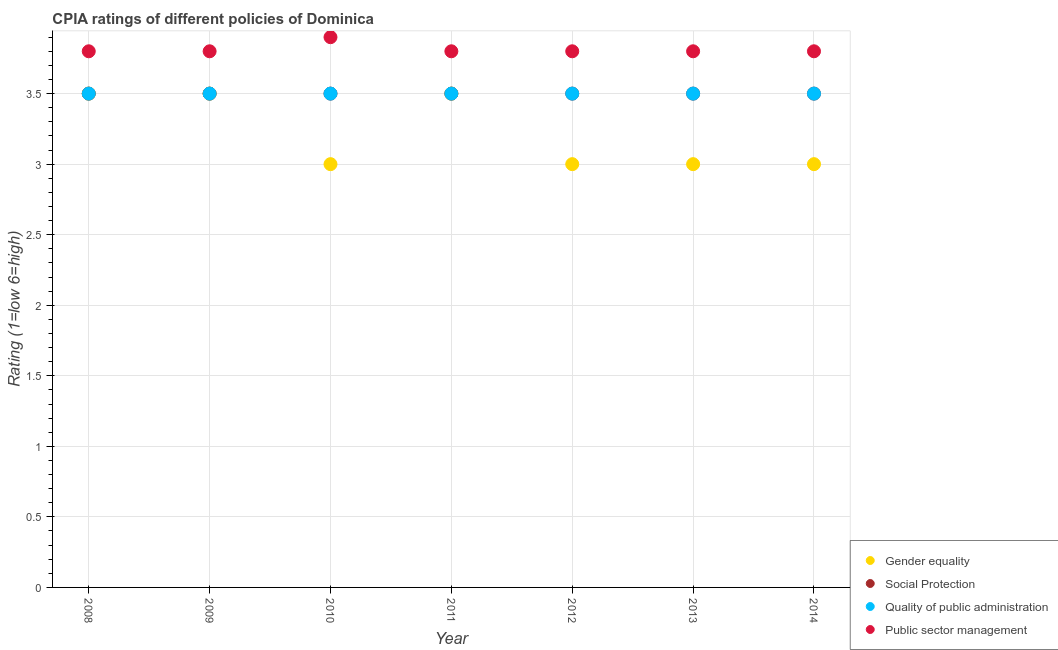Is the number of dotlines equal to the number of legend labels?
Your answer should be very brief. Yes. What is the cpia rating of gender equality in 2008?
Provide a succinct answer. 3.5. Across all years, what is the minimum cpia rating of quality of public administration?
Give a very brief answer. 3.5. In which year was the cpia rating of public sector management maximum?
Your response must be concise. 2010. In which year was the cpia rating of quality of public administration minimum?
Make the answer very short. 2008. What is the total cpia rating of public sector management in the graph?
Your answer should be compact. 26.7. What is the difference between the cpia rating of public sector management in 2010 and the cpia rating of quality of public administration in 2014?
Your response must be concise. 0.4. In the year 2013, what is the difference between the cpia rating of public sector management and cpia rating of gender equality?
Provide a short and direct response. 0.8. In how many years, is the cpia rating of gender equality greater than 1.2?
Give a very brief answer. 7. What is the ratio of the cpia rating of public sector management in 2008 to that in 2010?
Ensure brevity in your answer.  0.97. Is the difference between the cpia rating of social protection in 2011 and 2012 greater than the difference between the cpia rating of gender equality in 2011 and 2012?
Your response must be concise. No. What is the difference between the highest and the second highest cpia rating of social protection?
Ensure brevity in your answer.  0. Is it the case that in every year, the sum of the cpia rating of gender equality and cpia rating of social protection is greater than the cpia rating of quality of public administration?
Your answer should be compact. Yes. Does the cpia rating of social protection monotonically increase over the years?
Offer a terse response. No. Does the graph contain grids?
Your answer should be very brief. Yes. Where does the legend appear in the graph?
Keep it short and to the point. Bottom right. What is the title of the graph?
Give a very brief answer. CPIA ratings of different policies of Dominica. What is the label or title of the Y-axis?
Your response must be concise. Rating (1=low 6=high). What is the Rating (1=low 6=high) in Social Protection in 2008?
Ensure brevity in your answer.  3.5. What is the Rating (1=low 6=high) in Social Protection in 2009?
Your response must be concise. 3.5. What is the Rating (1=low 6=high) of Quality of public administration in 2009?
Give a very brief answer. 3.5. What is the Rating (1=low 6=high) in Gender equality in 2010?
Offer a terse response. 3. What is the Rating (1=low 6=high) of Social Protection in 2010?
Your response must be concise. 3.5. What is the Rating (1=low 6=high) in Quality of public administration in 2010?
Offer a terse response. 3.5. What is the Rating (1=low 6=high) of Public sector management in 2010?
Your answer should be very brief. 3.9. What is the Rating (1=low 6=high) of Quality of public administration in 2011?
Give a very brief answer. 3.5. What is the Rating (1=low 6=high) of Social Protection in 2012?
Offer a terse response. 3.5. What is the Rating (1=low 6=high) in Quality of public administration in 2012?
Your answer should be very brief. 3.5. What is the Rating (1=low 6=high) of Public sector management in 2012?
Ensure brevity in your answer.  3.8. What is the Rating (1=low 6=high) in Gender equality in 2014?
Provide a short and direct response. 3. What is the Rating (1=low 6=high) in Public sector management in 2014?
Your answer should be compact. 3.8. Across all years, what is the maximum Rating (1=low 6=high) of Gender equality?
Make the answer very short. 3.5. Across all years, what is the maximum Rating (1=low 6=high) in Public sector management?
Your answer should be very brief. 3.9. Across all years, what is the minimum Rating (1=low 6=high) in Gender equality?
Provide a succinct answer. 3. What is the total Rating (1=low 6=high) in Gender equality in the graph?
Ensure brevity in your answer.  22.5. What is the total Rating (1=low 6=high) of Quality of public administration in the graph?
Provide a succinct answer. 24.5. What is the total Rating (1=low 6=high) of Public sector management in the graph?
Offer a terse response. 26.7. What is the difference between the Rating (1=low 6=high) of Gender equality in 2008 and that in 2009?
Offer a very short reply. 0. What is the difference between the Rating (1=low 6=high) of Social Protection in 2008 and that in 2009?
Ensure brevity in your answer.  0. What is the difference between the Rating (1=low 6=high) in Social Protection in 2008 and that in 2010?
Offer a terse response. 0. What is the difference between the Rating (1=low 6=high) in Public sector management in 2008 and that in 2010?
Your answer should be compact. -0.1. What is the difference between the Rating (1=low 6=high) of Social Protection in 2008 and that in 2011?
Provide a succinct answer. 0. What is the difference between the Rating (1=low 6=high) in Quality of public administration in 2008 and that in 2011?
Provide a succinct answer. 0. What is the difference between the Rating (1=low 6=high) of Public sector management in 2008 and that in 2011?
Make the answer very short. 0. What is the difference between the Rating (1=low 6=high) in Quality of public administration in 2008 and that in 2012?
Provide a succinct answer. 0. What is the difference between the Rating (1=low 6=high) of Public sector management in 2008 and that in 2012?
Your answer should be compact. 0. What is the difference between the Rating (1=low 6=high) in Gender equality in 2008 and that in 2013?
Offer a very short reply. 0.5. What is the difference between the Rating (1=low 6=high) of Public sector management in 2008 and that in 2013?
Offer a very short reply. 0. What is the difference between the Rating (1=low 6=high) in Social Protection in 2008 and that in 2014?
Your answer should be very brief. 0. What is the difference between the Rating (1=low 6=high) of Quality of public administration in 2008 and that in 2014?
Your answer should be very brief. 0. What is the difference between the Rating (1=low 6=high) in Social Protection in 2009 and that in 2010?
Provide a short and direct response. 0. What is the difference between the Rating (1=low 6=high) of Public sector management in 2009 and that in 2010?
Your response must be concise. -0.1. What is the difference between the Rating (1=low 6=high) in Gender equality in 2009 and that in 2011?
Provide a succinct answer. 0. What is the difference between the Rating (1=low 6=high) in Quality of public administration in 2009 and that in 2011?
Ensure brevity in your answer.  0. What is the difference between the Rating (1=low 6=high) of Public sector management in 2009 and that in 2011?
Give a very brief answer. 0. What is the difference between the Rating (1=low 6=high) in Social Protection in 2009 and that in 2012?
Ensure brevity in your answer.  0. What is the difference between the Rating (1=low 6=high) of Quality of public administration in 2009 and that in 2012?
Offer a terse response. 0. What is the difference between the Rating (1=low 6=high) in Gender equality in 2009 and that in 2013?
Make the answer very short. 0.5. What is the difference between the Rating (1=low 6=high) of Social Protection in 2009 and that in 2013?
Provide a succinct answer. 0. What is the difference between the Rating (1=low 6=high) in Quality of public administration in 2009 and that in 2013?
Make the answer very short. 0. What is the difference between the Rating (1=low 6=high) in Quality of public administration in 2009 and that in 2014?
Provide a short and direct response. 0. What is the difference between the Rating (1=low 6=high) in Public sector management in 2009 and that in 2014?
Give a very brief answer. 0. What is the difference between the Rating (1=low 6=high) in Gender equality in 2010 and that in 2011?
Offer a terse response. -0.5. What is the difference between the Rating (1=low 6=high) in Public sector management in 2010 and that in 2013?
Offer a very short reply. 0.1. What is the difference between the Rating (1=low 6=high) of Public sector management in 2010 and that in 2014?
Offer a terse response. 0.1. What is the difference between the Rating (1=low 6=high) of Public sector management in 2011 and that in 2012?
Ensure brevity in your answer.  0. What is the difference between the Rating (1=low 6=high) of Quality of public administration in 2011 and that in 2013?
Your answer should be compact. 0. What is the difference between the Rating (1=low 6=high) in Public sector management in 2011 and that in 2013?
Offer a terse response. 0. What is the difference between the Rating (1=low 6=high) in Quality of public administration in 2011 and that in 2014?
Make the answer very short. 0. What is the difference between the Rating (1=low 6=high) in Public sector management in 2012 and that in 2013?
Make the answer very short. 0. What is the difference between the Rating (1=low 6=high) in Social Protection in 2012 and that in 2014?
Ensure brevity in your answer.  0. What is the difference between the Rating (1=low 6=high) of Public sector management in 2012 and that in 2014?
Provide a short and direct response. 0. What is the difference between the Rating (1=low 6=high) in Social Protection in 2013 and that in 2014?
Make the answer very short. 0. What is the difference between the Rating (1=low 6=high) in Public sector management in 2013 and that in 2014?
Provide a succinct answer. 0. What is the difference between the Rating (1=low 6=high) of Gender equality in 2008 and the Rating (1=low 6=high) of Quality of public administration in 2009?
Provide a short and direct response. 0. What is the difference between the Rating (1=low 6=high) in Quality of public administration in 2008 and the Rating (1=low 6=high) in Public sector management in 2009?
Make the answer very short. -0.3. What is the difference between the Rating (1=low 6=high) in Gender equality in 2008 and the Rating (1=low 6=high) in Social Protection in 2010?
Provide a succinct answer. 0. What is the difference between the Rating (1=low 6=high) in Gender equality in 2008 and the Rating (1=low 6=high) in Public sector management in 2010?
Provide a short and direct response. -0.4. What is the difference between the Rating (1=low 6=high) of Social Protection in 2008 and the Rating (1=low 6=high) of Quality of public administration in 2010?
Provide a short and direct response. 0. What is the difference between the Rating (1=low 6=high) in Gender equality in 2008 and the Rating (1=low 6=high) in Social Protection in 2011?
Provide a succinct answer. 0. What is the difference between the Rating (1=low 6=high) in Gender equality in 2008 and the Rating (1=low 6=high) in Quality of public administration in 2011?
Your answer should be compact. 0. What is the difference between the Rating (1=low 6=high) in Gender equality in 2008 and the Rating (1=low 6=high) in Public sector management in 2011?
Your answer should be very brief. -0.3. What is the difference between the Rating (1=low 6=high) in Social Protection in 2008 and the Rating (1=low 6=high) in Public sector management in 2011?
Provide a succinct answer. -0.3. What is the difference between the Rating (1=low 6=high) in Quality of public administration in 2008 and the Rating (1=low 6=high) in Public sector management in 2011?
Provide a short and direct response. -0.3. What is the difference between the Rating (1=low 6=high) in Gender equality in 2008 and the Rating (1=low 6=high) in Social Protection in 2012?
Your response must be concise. 0. What is the difference between the Rating (1=low 6=high) in Quality of public administration in 2008 and the Rating (1=low 6=high) in Public sector management in 2012?
Give a very brief answer. -0.3. What is the difference between the Rating (1=low 6=high) of Gender equality in 2008 and the Rating (1=low 6=high) of Social Protection in 2013?
Your response must be concise. 0. What is the difference between the Rating (1=low 6=high) in Gender equality in 2008 and the Rating (1=low 6=high) in Quality of public administration in 2013?
Make the answer very short. 0. What is the difference between the Rating (1=low 6=high) of Social Protection in 2008 and the Rating (1=low 6=high) of Public sector management in 2013?
Your answer should be compact. -0.3. What is the difference between the Rating (1=low 6=high) in Quality of public administration in 2008 and the Rating (1=low 6=high) in Public sector management in 2014?
Keep it short and to the point. -0.3. What is the difference between the Rating (1=low 6=high) of Gender equality in 2009 and the Rating (1=low 6=high) of Social Protection in 2010?
Offer a very short reply. 0. What is the difference between the Rating (1=low 6=high) of Gender equality in 2009 and the Rating (1=low 6=high) of Quality of public administration in 2010?
Provide a succinct answer. 0. What is the difference between the Rating (1=low 6=high) in Social Protection in 2009 and the Rating (1=low 6=high) in Quality of public administration in 2010?
Make the answer very short. 0. What is the difference between the Rating (1=low 6=high) of Social Protection in 2009 and the Rating (1=low 6=high) of Public sector management in 2010?
Your response must be concise. -0.4. What is the difference between the Rating (1=low 6=high) in Gender equality in 2009 and the Rating (1=low 6=high) in Social Protection in 2011?
Your response must be concise. 0. What is the difference between the Rating (1=low 6=high) in Gender equality in 2009 and the Rating (1=low 6=high) in Public sector management in 2011?
Offer a very short reply. -0.3. What is the difference between the Rating (1=low 6=high) of Social Protection in 2009 and the Rating (1=low 6=high) of Public sector management in 2011?
Make the answer very short. -0.3. What is the difference between the Rating (1=low 6=high) in Gender equality in 2009 and the Rating (1=low 6=high) in Quality of public administration in 2012?
Your answer should be very brief. 0. What is the difference between the Rating (1=low 6=high) in Gender equality in 2009 and the Rating (1=low 6=high) in Public sector management in 2012?
Offer a terse response. -0.3. What is the difference between the Rating (1=low 6=high) in Quality of public administration in 2009 and the Rating (1=low 6=high) in Public sector management in 2012?
Provide a short and direct response. -0.3. What is the difference between the Rating (1=low 6=high) in Gender equality in 2009 and the Rating (1=low 6=high) in Social Protection in 2013?
Provide a succinct answer. 0. What is the difference between the Rating (1=low 6=high) in Social Protection in 2009 and the Rating (1=low 6=high) in Public sector management in 2013?
Ensure brevity in your answer.  -0.3. What is the difference between the Rating (1=low 6=high) of Quality of public administration in 2009 and the Rating (1=low 6=high) of Public sector management in 2013?
Keep it short and to the point. -0.3. What is the difference between the Rating (1=low 6=high) of Gender equality in 2009 and the Rating (1=low 6=high) of Social Protection in 2014?
Keep it short and to the point. 0. What is the difference between the Rating (1=low 6=high) of Gender equality in 2009 and the Rating (1=low 6=high) of Quality of public administration in 2014?
Offer a terse response. 0. What is the difference between the Rating (1=low 6=high) in Gender equality in 2009 and the Rating (1=low 6=high) in Public sector management in 2014?
Provide a succinct answer. -0.3. What is the difference between the Rating (1=low 6=high) of Gender equality in 2010 and the Rating (1=low 6=high) of Quality of public administration in 2011?
Provide a short and direct response. -0.5. What is the difference between the Rating (1=low 6=high) in Gender equality in 2010 and the Rating (1=low 6=high) in Public sector management in 2011?
Offer a very short reply. -0.8. What is the difference between the Rating (1=low 6=high) in Quality of public administration in 2010 and the Rating (1=low 6=high) in Public sector management in 2011?
Ensure brevity in your answer.  -0.3. What is the difference between the Rating (1=low 6=high) of Gender equality in 2010 and the Rating (1=low 6=high) of Public sector management in 2012?
Provide a short and direct response. -0.8. What is the difference between the Rating (1=low 6=high) of Social Protection in 2010 and the Rating (1=low 6=high) of Quality of public administration in 2012?
Offer a terse response. 0. What is the difference between the Rating (1=low 6=high) in Social Protection in 2010 and the Rating (1=low 6=high) in Public sector management in 2012?
Provide a succinct answer. -0.3. What is the difference between the Rating (1=low 6=high) in Gender equality in 2010 and the Rating (1=low 6=high) in Quality of public administration in 2013?
Offer a very short reply. -0.5. What is the difference between the Rating (1=low 6=high) of Gender equality in 2010 and the Rating (1=low 6=high) of Public sector management in 2013?
Give a very brief answer. -0.8. What is the difference between the Rating (1=low 6=high) in Social Protection in 2010 and the Rating (1=low 6=high) in Quality of public administration in 2013?
Ensure brevity in your answer.  0. What is the difference between the Rating (1=low 6=high) in Social Protection in 2010 and the Rating (1=low 6=high) in Public sector management in 2013?
Ensure brevity in your answer.  -0.3. What is the difference between the Rating (1=low 6=high) of Quality of public administration in 2010 and the Rating (1=low 6=high) of Public sector management in 2013?
Make the answer very short. -0.3. What is the difference between the Rating (1=low 6=high) of Gender equality in 2010 and the Rating (1=low 6=high) of Social Protection in 2014?
Offer a very short reply. -0.5. What is the difference between the Rating (1=low 6=high) in Social Protection in 2010 and the Rating (1=low 6=high) in Public sector management in 2014?
Offer a very short reply. -0.3. What is the difference between the Rating (1=low 6=high) of Gender equality in 2011 and the Rating (1=low 6=high) of Quality of public administration in 2012?
Provide a succinct answer. 0. What is the difference between the Rating (1=low 6=high) of Gender equality in 2011 and the Rating (1=low 6=high) of Public sector management in 2012?
Give a very brief answer. -0.3. What is the difference between the Rating (1=low 6=high) of Gender equality in 2011 and the Rating (1=low 6=high) of Quality of public administration in 2013?
Keep it short and to the point. 0. What is the difference between the Rating (1=low 6=high) in Gender equality in 2011 and the Rating (1=low 6=high) in Public sector management in 2013?
Give a very brief answer. -0.3. What is the difference between the Rating (1=low 6=high) of Social Protection in 2011 and the Rating (1=low 6=high) of Quality of public administration in 2013?
Make the answer very short. 0. What is the difference between the Rating (1=low 6=high) of Quality of public administration in 2011 and the Rating (1=low 6=high) of Public sector management in 2013?
Your response must be concise. -0.3. What is the difference between the Rating (1=low 6=high) of Gender equality in 2011 and the Rating (1=low 6=high) of Social Protection in 2014?
Make the answer very short. 0. What is the difference between the Rating (1=low 6=high) in Gender equality in 2011 and the Rating (1=low 6=high) in Public sector management in 2014?
Provide a short and direct response. -0.3. What is the difference between the Rating (1=low 6=high) in Social Protection in 2011 and the Rating (1=low 6=high) in Quality of public administration in 2014?
Offer a very short reply. 0. What is the difference between the Rating (1=low 6=high) in Gender equality in 2012 and the Rating (1=low 6=high) in Public sector management in 2013?
Provide a short and direct response. -0.8. What is the difference between the Rating (1=low 6=high) in Social Protection in 2012 and the Rating (1=low 6=high) in Public sector management in 2013?
Your answer should be compact. -0.3. What is the difference between the Rating (1=low 6=high) of Quality of public administration in 2012 and the Rating (1=low 6=high) of Public sector management in 2013?
Offer a very short reply. -0.3. What is the difference between the Rating (1=low 6=high) of Gender equality in 2012 and the Rating (1=low 6=high) of Social Protection in 2014?
Your answer should be compact. -0.5. What is the difference between the Rating (1=low 6=high) of Gender equality in 2012 and the Rating (1=low 6=high) of Quality of public administration in 2014?
Offer a very short reply. -0.5. What is the difference between the Rating (1=low 6=high) in Gender equality in 2012 and the Rating (1=low 6=high) in Public sector management in 2014?
Offer a terse response. -0.8. What is the difference between the Rating (1=low 6=high) of Quality of public administration in 2012 and the Rating (1=low 6=high) of Public sector management in 2014?
Make the answer very short. -0.3. What is the difference between the Rating (1=low 6=high) of Gender equality in 2013 and the Rating (1=low 6=high) of Social Protection in 2014?
Ensure brevity in your answer.  -0.5. What is the difference between the Rating (1=low 6=high) in Gender equality in 2013 and the Rating (1=low 6=high) in Public sector management in 2014?
Give a very brief answer. -0.8. What is the difference between the Rating (1=low 6=high) of Social Protection in 2013 and the Rating (1=low 6=high) of Public sector management in 2014?
Your answer should be very brief. -0.3. What is the average Rating (1=low 6=high) in Gender equality per year?
Make the answer very short. 3.21. What is the average Rating (1=low 6=high) in Quality of public administration per year?
Ensure brevity in your answer.  3.5. What is the average Rating (1=low 6=high) in Public sector management per year?
Offer a terse response. 3.81. In the year 2008, what is the difference between the Rating (1=low 6=high) in Gender equality and Rating (1=low 6=high) in Quality of public administration?
Keep it short and to the point. 0. In the year 2008, what is the difference between the Rating (1=low 6=high) in Social Protection and Rating (1=low 6=high) in Quality of public administration?
Give a very brief answer. 0. In the year 2009, what is the difference between the Rating (1=low 6=high) in Gender equality and Rating (1=low 6=high) in Social Protection?
Provide a succinct answer. 0. In the year 2009, what is the difference between the Rating (1=low 6=high) of Gender equality and Rating (1=low 6=high) of Quality of public administration?
Provide a short and direct response. 0. In the year 2009, what is the difference between the Rating (1=low 6=high) of Gender equality and Rating (1=low 6=high) of Public sector management?
Provide a short and direct response. -0.3. In the year 2009, what is the difference between the Rating (1=low 6=high) of Social Protection and Rating (1=low 6=high) of Public sector management?
Keep it short and to the point. -0.3. In the year 2009, what is the difference between the Rating (1=low 6=high) of Quality of public administration and Rating (1=low 6=high) of Public sector management?
Offer a terse response. -0.3. In the year 2010, what is the difference between the Rating (1=low 6=high) of Gender equality and Rating (1=low 6=high) of Quality of public administration?
Provide a short and direct response. -0.5. In the year 2010, what is the difference between the Rating (1=low 6=high) in Quality of public administration and Rating (1=low 6=high) in Public sector management?
Your answer should be compact. -0.4. In the year 2011, what is the difference between the Rating (1=low 6=high) in Gender equality and Rating (1=low 6=high) in Quality of public administration?
Make the answer very short. 0. In the year 2011, what is the difference between the Rating (1=low 6=high) in Social Protection and Rating (1=low 6=high) in Public sector management?
Your response must be concise. -0.3. In the year 2011, what is the difference between the Rating (1=low 6=high) in Quality of public administration and Rating (1=low 6=high) in Public sector management?
Keep it short and to the point. -0.3. In the year 2012, what is the difference between the Rating (1=low 6=high) in Gender equality and Rating (1=low 6=high) in Social Protection?
Give a very brief answer. -0.5. In the year 2012, what is the difference between the Rating (1=low 6=high) in Social Protection and Rating (1=low 6=high) in Quality of public administration?
Offer a very short reply. 0. In the year 2012, what is the difference between the Rating (1=low 6=high) of Social Protection and Rating (1=low 6=high) of Public sector management?
Your answer should be very brief. -0.3. In the year 2012, what is the difference between the Rating (1=low 6=high) of Quality of public administration and Rating (1=low 6=high) of Public sector management?
Ensure brevity in your answer.  -0.3. In the year 2013, what is the difference between the Rating (1=low 6=high) of Gender equality and Rating (1=low 6=high) of Quality of public administration?
Your response must be concise. -0.5. In the year 2013, what is the difference between the Rating (1=low 6=high) in Gender equality and Rating (1=low 6=high) in Public sector management?
Your response must be concise. -0.8. In the year 2013, what is the difference between the Rating (1=low 6=high) of Social Protection and Rating (1=low 6=high) of Public sector management?
Ensure brevity in your answer.  -0.3. In the year 2013, what is the difference between the Rating (1=low 6=high) of Quality of public administration and Rating (1=low 6=high) of Public sector management?
Your response must be concise. -0.3. In the year 2014, what is the difference between the Rating (1=low 6=high) in Gender equality and Rating (1=low 6=high) in Social Protection?
Provide a short and direct response. -0.5. In the year 2014, what is the difference between the Rating (1=low 6=high) in Gender equality and Rating (1=low 6=high) in Quality of public administration?
Keep it short and to the point. -0.5. In the year 2014, what is the difference between the Rating (1=low 6=high) in Gender equality and Rating (1=low 6=high) in Public sector management?
Provide a succinct answer. -0.8. In the year 2014, what is the difference between the Rating (1=low 6=high) of Social Protection and Rating (1=low 6=high) of Public sector management?
Provide a short and direct response. -0.3. What is the ratio of the Rating (1=low 6=high) of Gender equality in 2008 to that in 2009?
Provide a short and direct response. 1. What is the ratio of the Rating (1=low 6=high) in Gender equality in 2008 to that in 2010?
Ensure brevity in your answer.  1.17. What is the ratio of the Rating (1=low 6=high) in Public sector management in 2008 to that in 2010?
Keep it short and to the point. 0.97. What is the ratio of the Rating (1=low 6=high) of Social Protection in 2008 to that in 2011?
Your response must be concise. 1. What is the ratio of the Rating (1=low 6=high) in Public sector management in 2008 to that in 2011?
Ensure brevity in your answer.  1. What is the ratio of the Rating (1=low 6=high) in Social Protection in 2008 to that in 2012?
Ensure brevity in your answer.  1. What is the ratio of the Rating (1=low 6=high) in Quality of public administration in 2008 to that in 2012?
Your answer should be very brief. 1. What is the ratio of the Rating (1=low 6=high) of Gender equality in 2008 to that in 2013?
Provide a succinct answer. 1.17. What is the ratio of the Rating (1=low 6=high) in Quality of public administration in 2008 to that in 2013?
Your answer should be very brief. 1. What is the ratio of the Rating (1=low 6=high) of Gender equality in 2008 to that in 2014?
Provide a succinct answer. 1.17. What is the ratio of the Rating (1=low 6=high) of Quality of public administration in 2008 to that in 2014?
Your answer should be very brief. 1. What is the ratio of the Rating (1=low 6=high) of Public sector management in 2008 to that in 2014?
Provide a succinct answer. 1. What is the ratio of the Rating (1=low 6=high) in Gender equality in 2009 to that in 2010?
Offer a very short reply. 1.17. What is the ratio of the Rating (1=low 6=high) of Public sector management in 2009 to that in 2010?
Provide a succinct answer. 0.97. What is the ratio of the Rating (1=low 6=high) in Gender equality in 2009 to that in 2011?
Your answer should be compact. 1. What is the ratio of the Rating (1=low 6=high) in Public sector management in 2009 to that in 2011?
Ensure brevity in your answer.  1. What is the ratio of the Rating (1=low 6=high) of Quality of public administration in 2009 to that in 2012?
Your response must be concise. 1. What is the ratio of the Rating (1=low 6=high) in Public sector management in 2009 to that in 2012?
Ensure brevity in your answer.  1. What is the ratio of the Rating (1=low 6=high) of Gender equality in 2009 to that in 2013?
Keep it short and to the point. 1.17. What is the ratio of the Rating (1=low 6=high) in Social Protection in 2009 to that in 2013?
Keep it short and to the point. 1. What is the ratio of the Rating (1=low 6=high) of Gender equality in 2009 to that in 2014?
Offer a very short reply. 1.17. What is the ratio of the Rating (1=low 6=high) in Social Protection in 2009 to that in 2014?
Ensure brevity in your answer.  1. What is the ratio of the Rating (1=low 6=high) of Gender equality in 2010 to that in 2011?
Make the answer very short. 0.86. What is the ratio of the Rating (1=low 6=high) of Social Protection in 2010 to that in 2011?
Your answer should be compact. 1. What is the ratio of the Rating (1=low 6=high) in Quality of public administration in 2010 to that in 2011?
Provide a succinct answer. 1. What is the ratio of the Rating (1=low 6=high) of Public sector management in 2010 to that in 2011?
Your answer should be very brief. 1.03. What is the ratio of the Rating (1=low 6=high) in Quality of public administration in 2010 to that in 2012?
Provide a short and direct response. 1. What is the ratio of the Rating (1=low 6=high) of Public sector management in 2010 to that in 2012?
Ensure brevity in your answer.  1.03. What is the ratio of the Rating (1=low 6=high) of Gender equality in 2010 to that in 2013?
Ensure brevity in your answer.  1. What is the ratio of the Rating (1=low 6=high) of Public sector management in 2010 to that in 2013?
Offer a very short reply. 1.03. What is the ratio of the Rating (1=low 6=high) of Social Protection in 2010 to that in 2014?
Provide a short and direct response. 1. What is the ratio of the Rating (1=low 6=high) in Public sector management in 2010 to that in 2014?
Offer a terse response. 1.03. What is the ratio of the Rating (1=low 6=high) of Social Protection in 2011 to that in 2012?
Your answer should be compact. 1. What is the ratio of the Rating (1=low 6=high) in Quality of public administration in 2011 to that in 2012?
Provide a short and direct response. 1. What is the ratio of the Rating (1=low 6=high) in Gender equality in 2011 to that in 2013?
Provide a succinct answer. 1.17. What is the ratio of the Rating (1=low 6=high) of Social Protection in 2011 to that in 2014?
Provide a succinct answer. 1. What is the ratio of the Rating (1=low 6=high) of Quality of public administration in 2011 to that in 2014?
Keep it short and to the point. 1. What is the ratio of the Rating (1=low 6=high) of Public sector management in 2012 to that in 2013?
Offer a terse response. 1. What is the ratio of the Rating (1=low 6=high) of Gender equality in 2012 to that in 2014?
Offer a very short reply. 1. What is the ratio of the Rating (1=low 6=high) of Social Protection in 2012 to that in 2014?
Make the answer very short. 1. What is the ratio of the Rating (1=low 6=high) of Quality of public administration in 2012 to that in 2014?
Provide a short and direct response. 1. What is the ratio of the Rating (1=low 6=high) in Gender equality in 2013 to that in 2014?
Your answer should be very brief. 1. What is the ratio of the Rating (1=low 6=high) of Social Protection in 2013 to that in 2014?
Give a very brief answer. 1. What is the difference between the highest and the second highest Rating (1=low 6=high) of Quality of public administration?
Offer a very short reply. 0. What is the difference between the highest and the lowest Rating (1=low 6=high) of Social Protection?
Your response must be concise. 0. What is the difference between the highest and the lowest Rating (1=low 6=high) of Public sector management?
Ensure brevity in your answer.  0.1. 